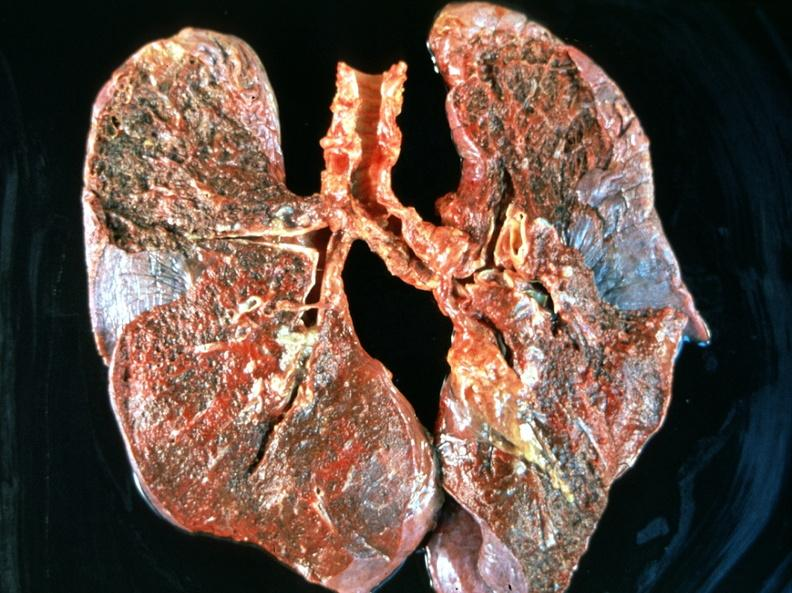does this image show breast cancer metastasis to lung?
Answer the question using a single word or phrase. Yes 